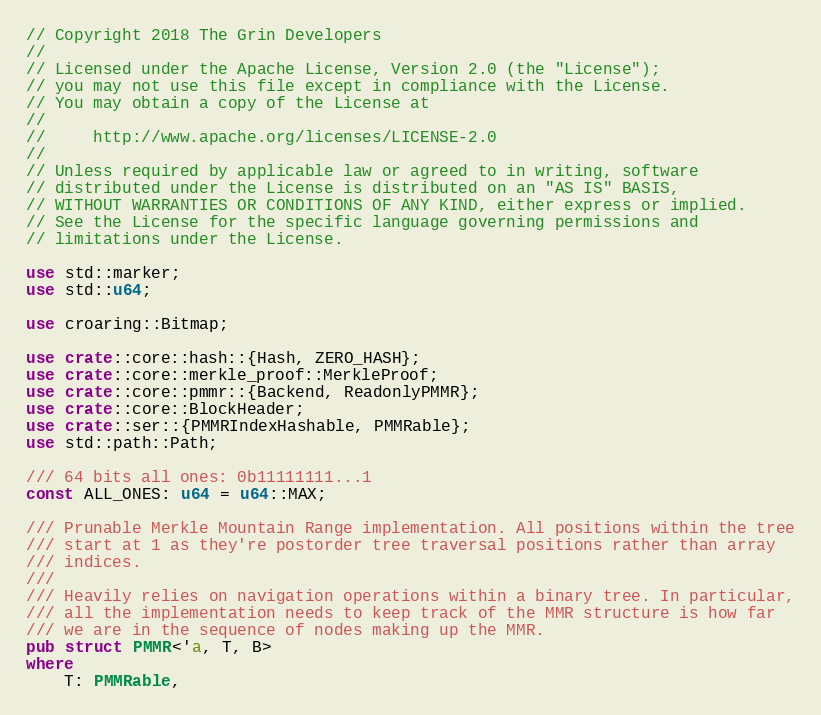Convert code to text. <code><loc_0><loc_0><loc_500><loc_500><_Rust_>// Copyright 2018 The Grin Developers
//
// Licensed under the Apache License, Version 2.0 (the "License");
// you may not use this file except in compliance with the License.
// You may obtain a copy of the License at
//
//     http://www.apache.org/licenses/LICENSE-2.0
//
// Unless required by applicable law or agreed to in writing, software
// distributed under the License is distributed on an "AS IS" BASIS,
// WITHOUT WARRANTIES OR CONDITIONS OF ANY KIND, either express or implied.
// See the License for the specific language governing permissions and
// limitations under the License.

use std::marker;
use std::u64;

use croaring::Bitmap;

use crate::core::hash::{Hash, ZERO_HASH};
use crate::core::merkle_proof::MerkleProof;
use crate::core::pmmr::{Backend, ReadonlyPMMR};
use crate::core::BlockHeader;
use crate::ser::{PMMRIndexHashable, PMMRable};
use std::path::Path;

/// 64 bits all ones: 0b11111111...1
const ALL_ONES: u64 = u64::MAX;

/// Prunable Merkle Mountain Range implementation. All positions within the tree
/// start at 1 as they're postorder tree traversal positions rather than array
/// indices.
///
/// Heavily relies on navigation operations within a binary tree. In particular,
/// all the implementation needs to keep track of the MMR structure is how far
/// we are in the sequence of nodes making up the MMR.
pub struct PMMR<'a, T, B>
where
	T: PMMRable,</code> 